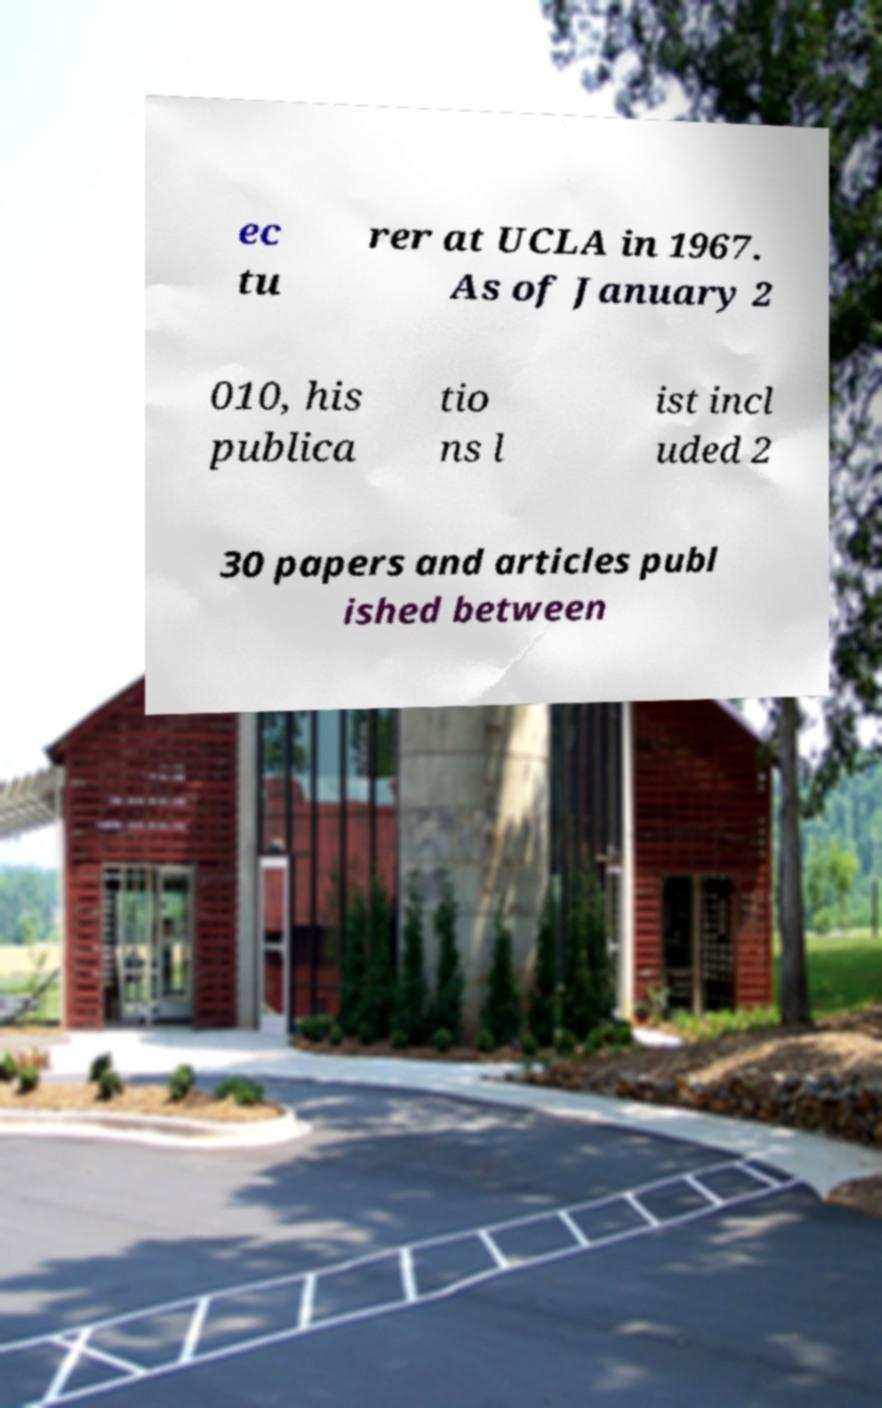Could you extract and type out the text from this image? ec tu rer at UCLA in 1967. As of January 2 010, his publica tio ns l ist incl uded 2 30 papers and articles publ ished between 